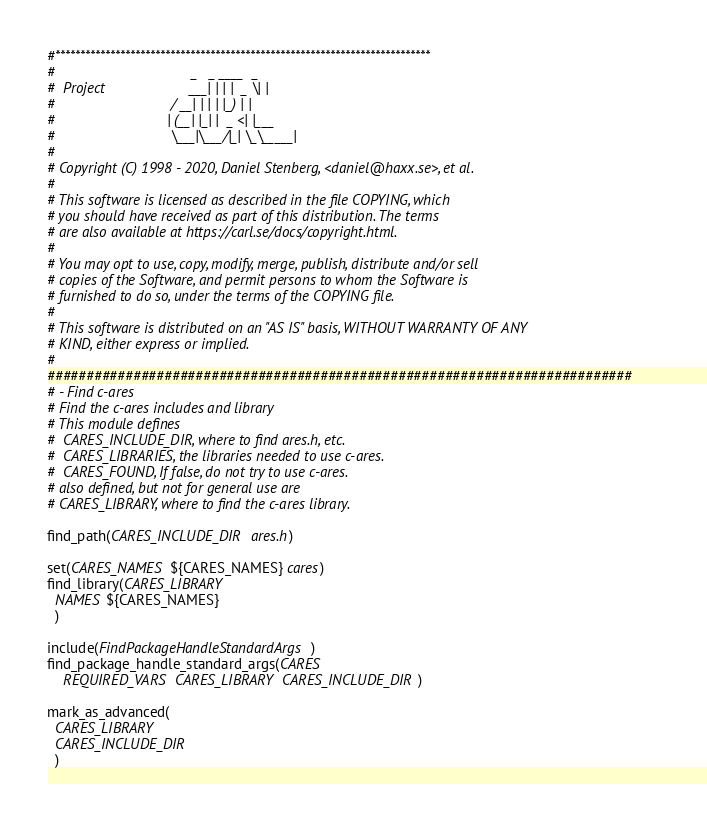Convert code to text. <code><loc_0><loc_0><loc_500><loc_500><_CMake_>#***************************************************************************
#                                  _   _ ____  _
#  Project                     ___| | | |  _ \| |
#                             / __| | | | |_) | |
#                            | (__| |_| |  _ <| |___
#                             \___|\___/|_| \_\_____|
#
# Copyright (C) 1998 - 2020, Daniel Stenberg, <daniel@haxx.se>, et al.
#
# This software is licensed as described in the file COPYING, which
# you should have received as part of this distribution. The terms
# are also available at https://carl.se/docs/copyright.html.
#
# You may opt to use, copy, modify, merge, publish, distribute and/or sell
# copies of the Software, and permit persons to whom the Software is
# furnished to do so, under the terms of the COPYING file.
#
# This software is distributed on an "AS IS" basis, WITHOUT WARRANTY OF ANY
# KIND, either express or implied.
#
###########################################################################
# - Find c-ares
# Find the c-ares includes and library
# This module defines
#  CARES_INCLUDE_DIR, where to find ares.h, etc.
#  CARES_LIBRARIES, the libraries needed to use c-ares.
#  CARES_FOUND, If false, do not try to use c-ares.
# also defined, but not for general use are
# CARES_LIBRARY, where to find the c-ares library.

find_path(CARES_INCLUDE_DIR ares.h)

set(CARES_NAMES ${CARES_NAMES} cares)
find_library(CARES_LIBRARY
  NAMES ${CARES_NAMES}
  )

include(FindPackageHandleStandardArgs)
find_package_handle_standard_args(CARES
    REQUIRED_VARS CARES_LIBRARY CARES_INCLUDE_DIR)

mark_as_advanced(
  CARES_LIBRARY
  CARES_INCLUDE_DIR
  )
</code> 